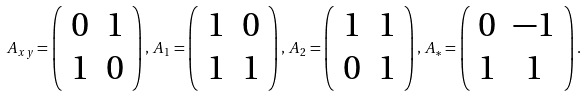<formula> <loc_0><loc_0><loc_500><loc_500>A _ { x y } = \left ( \begin{array} { c c } 0 & 1 \\ 1 & 0 \end{array} \right ) , \, A _ { 1 } = \left ( \begin{array} { c c } 1 & 0 \\ 1 & 1 \end{array} \right ) , \, A _ { 2 } = \left ( \begin{array} { c c } 1 & 1 \\ 0 & 1 \end{array} \right ) , \, A _ { * } = \left ( \begin{array} { c c } 0 & - 1 \\ 1 & 1 \end{array} \right ) .</formula> 